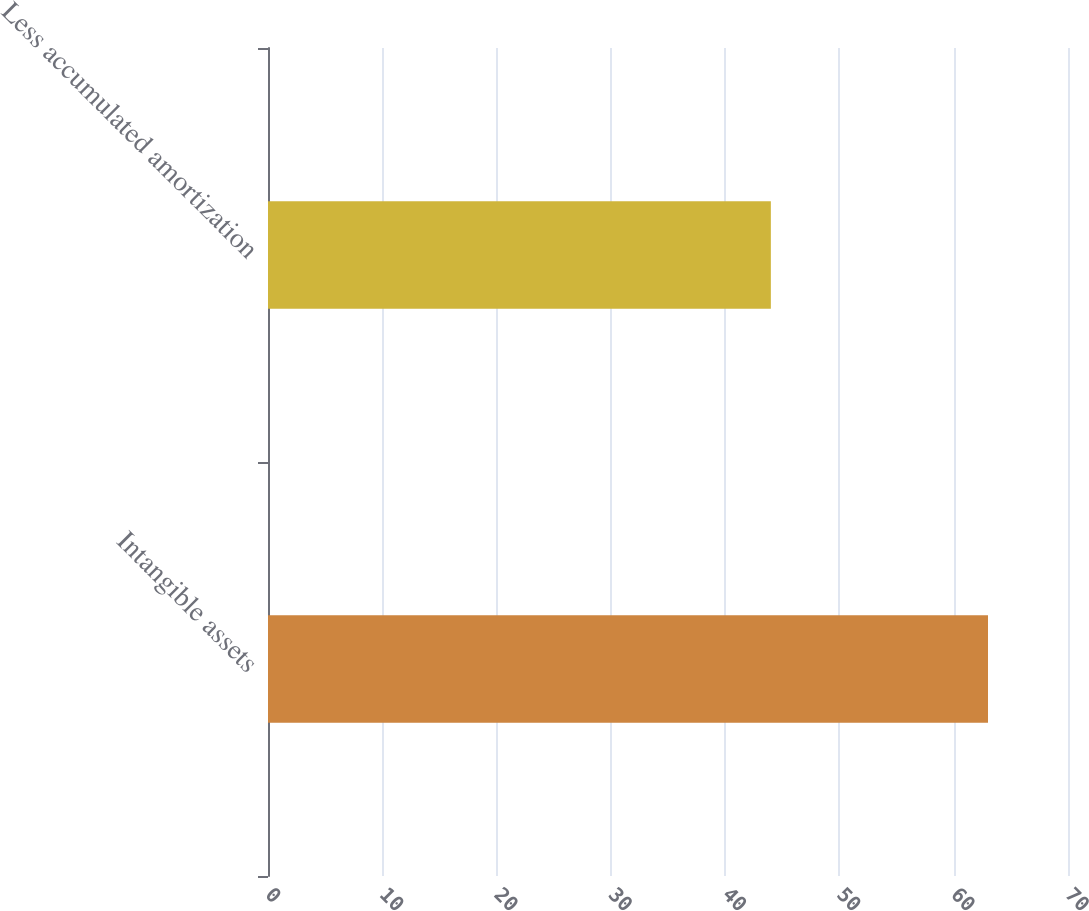Convert chart to OTSL. <chart><loc_0><loc_0><loc_500><loc_500><bar_chart><fcel>Intangible assets<fcel>Less accumulated amortization<nl><fcel>63<fcel>44<nl></chart> 